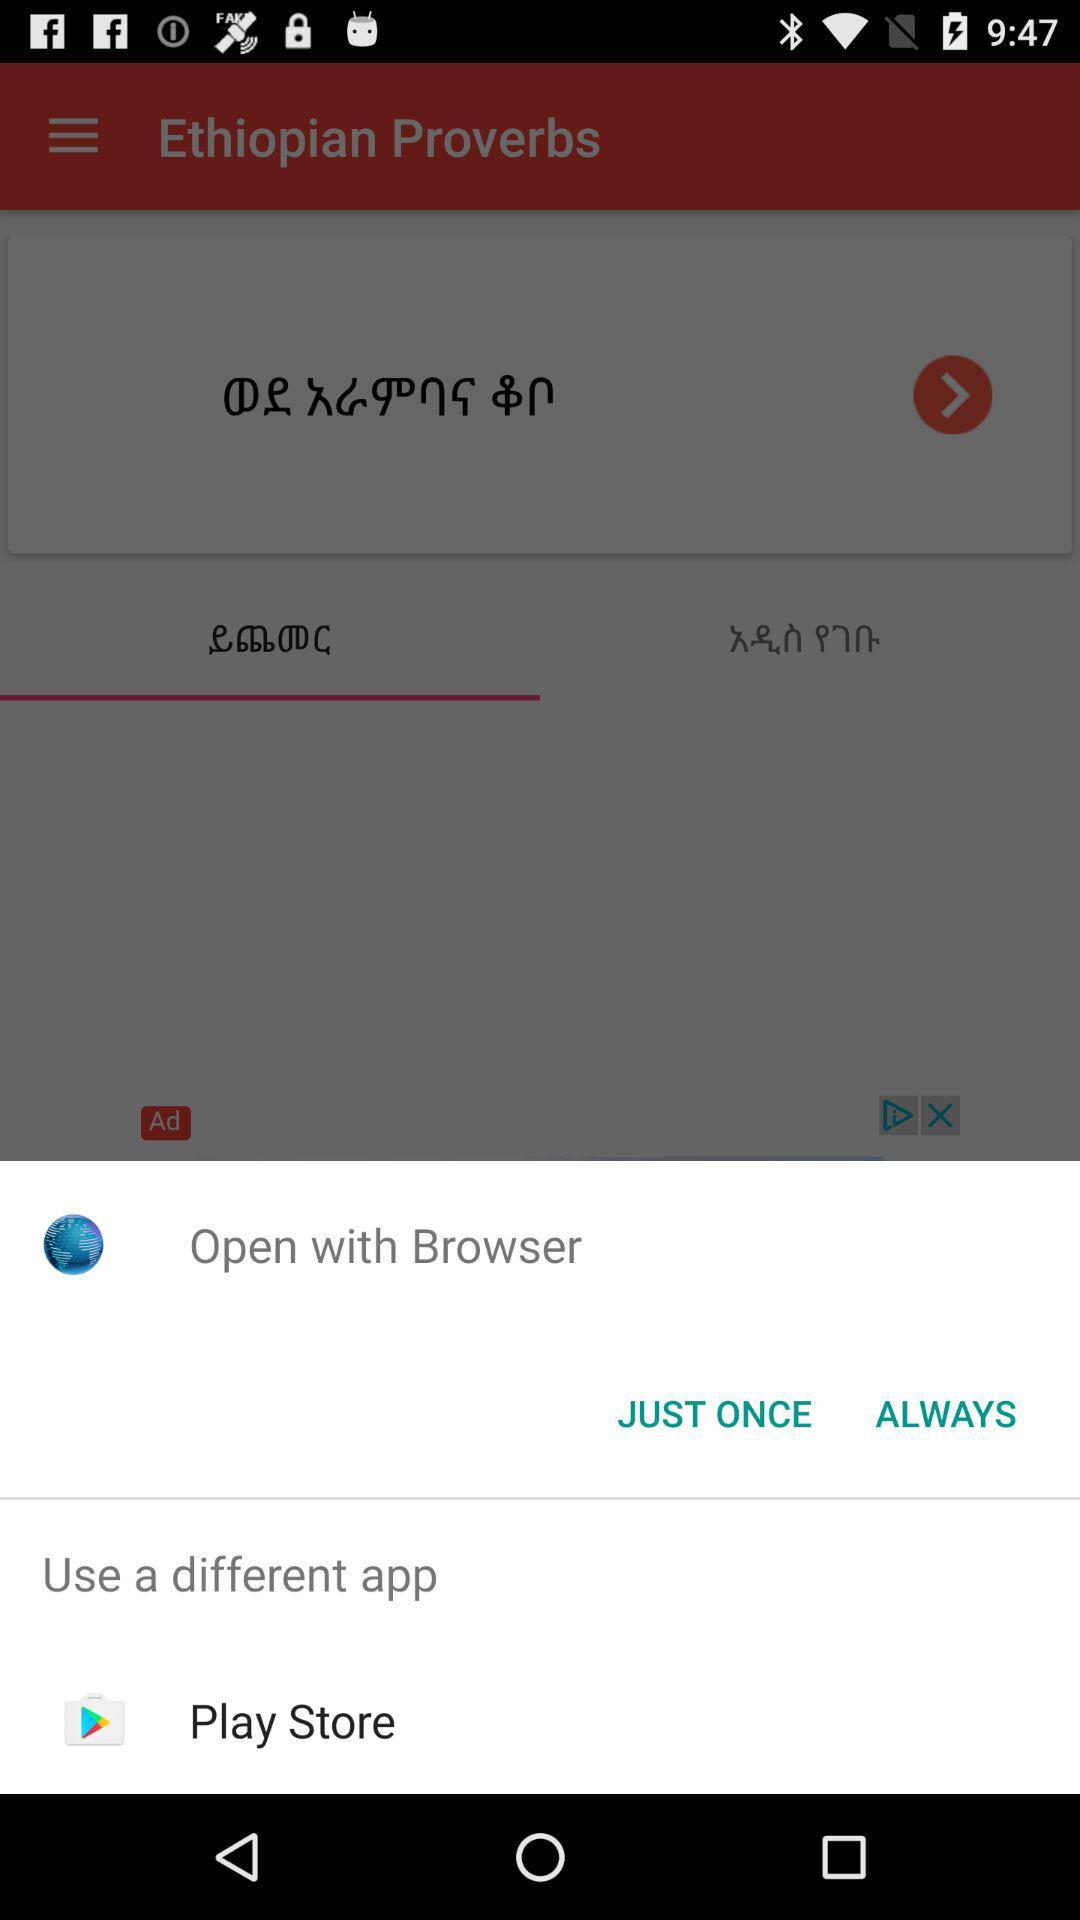Name that Different Application use to run the Commanded action?
When the provided information is insufficient, respond with <no answer>. <no answer> 